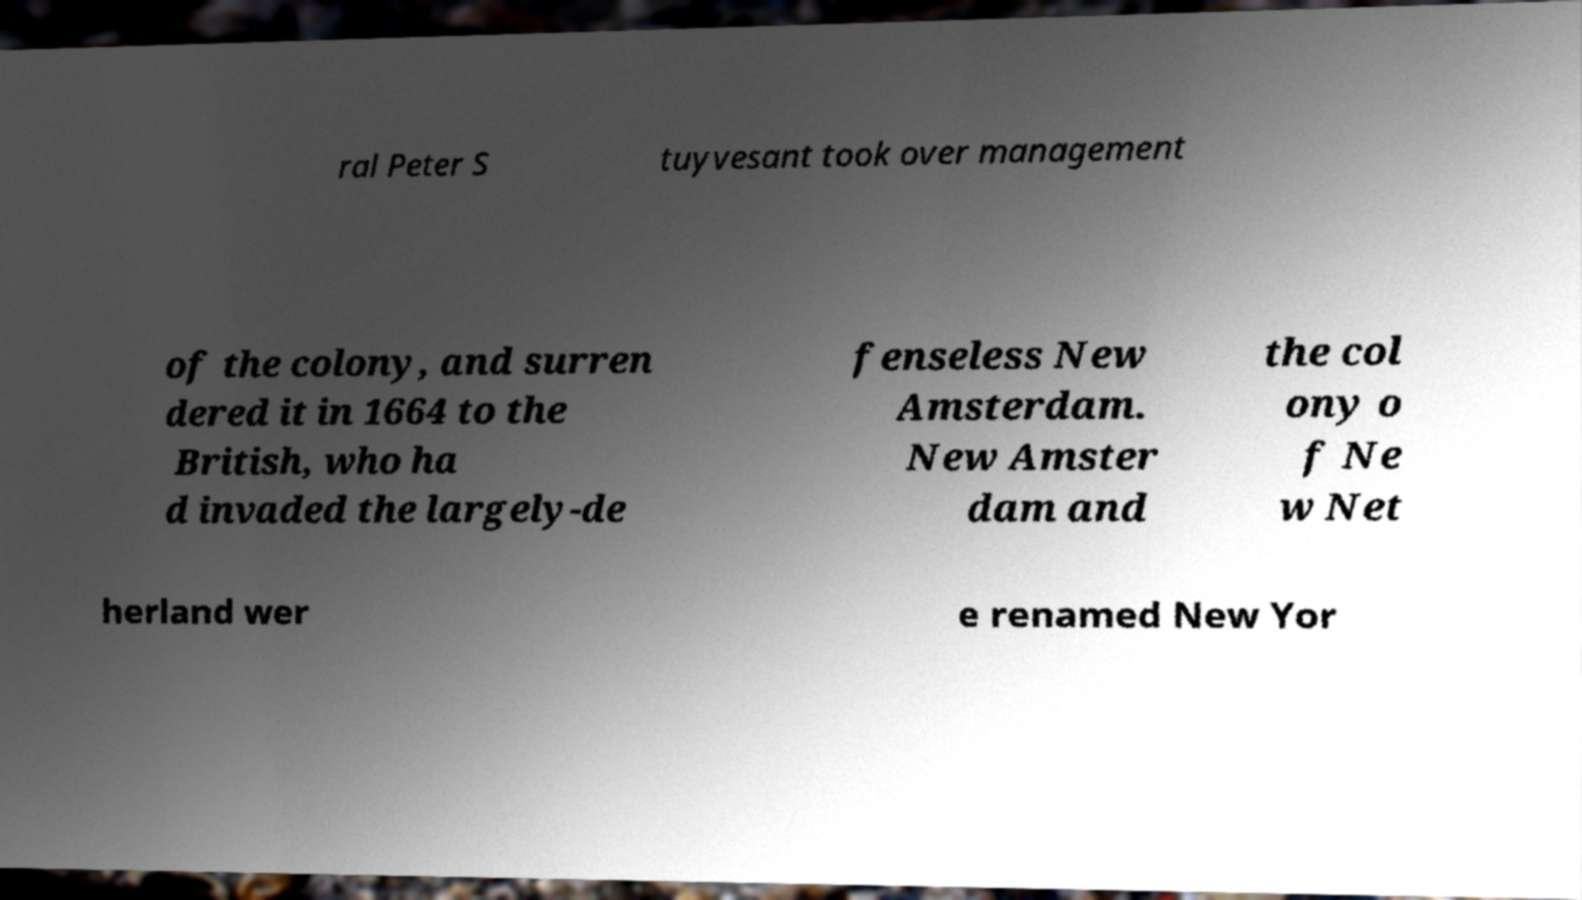For documentation purposes, I need the text within this image transcribed. Could you provide that? ral Peter S tuyvesant took over management of the colony, and surren dered it in 1664 to the British, who ha d invaded the largely-de fenseless New Amsterdam. New Amster dam and the col ony o f Ne w Net herland wer e renamed New Yor 